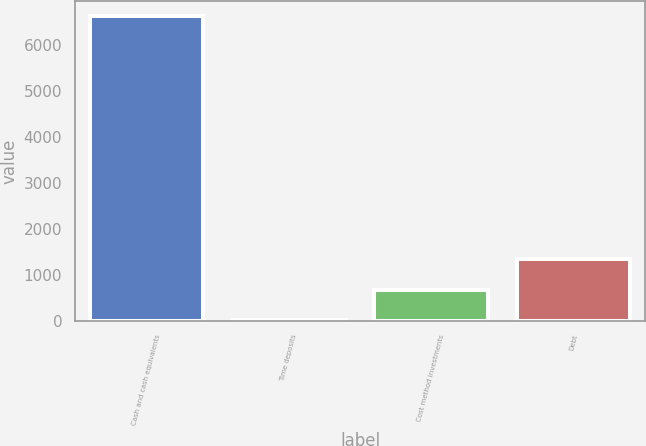<chart> <loc_0><loc_0><loc_500><loc_500><bar_chart><fcel>Cash and cash equivalents<fcel>Time deposits<fcel>Cost method investments<fcel>Debt<nl><fcel>6610.8<fcel>12.3<fcel>672.15<fcel>1332<nl></chart> 